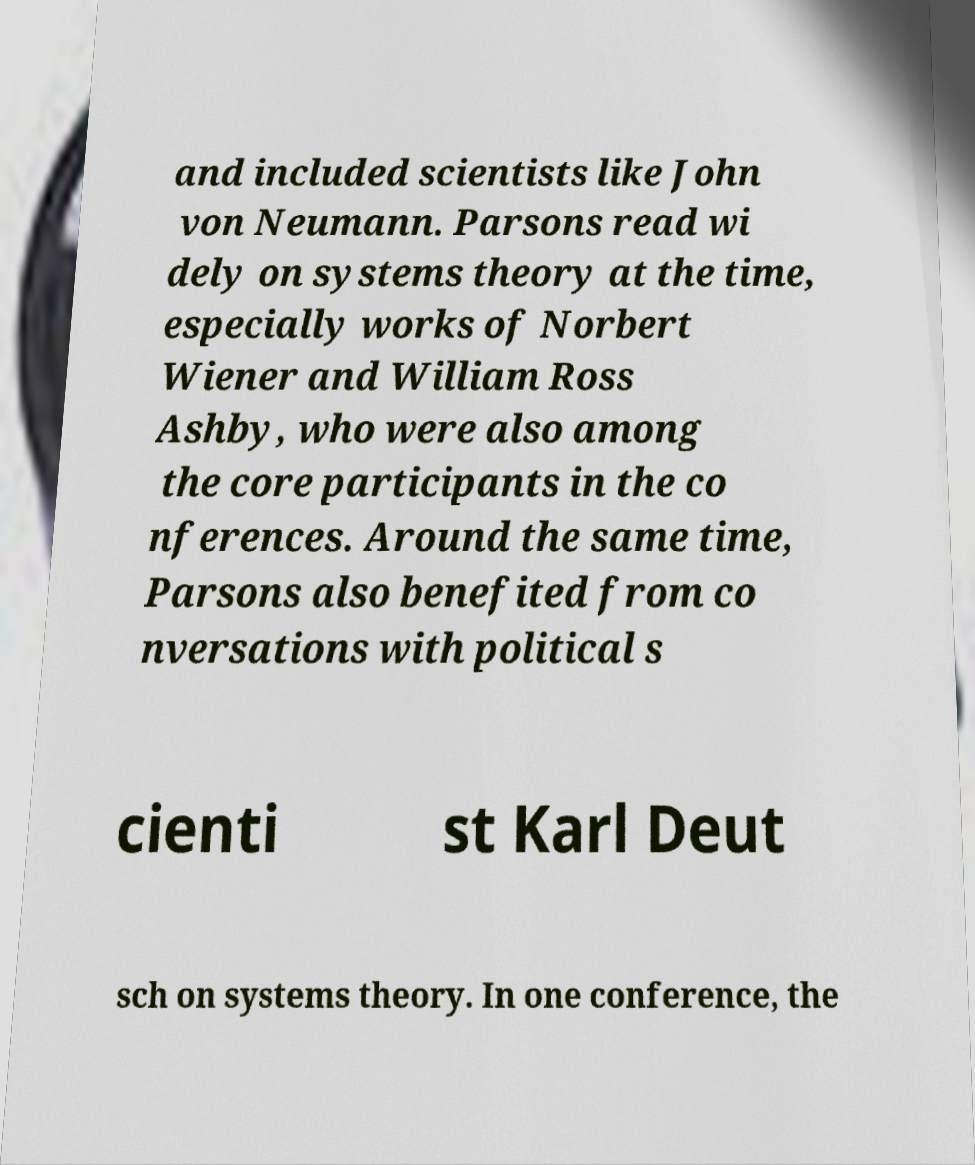Please identify and transcribe the text found in this image. and included scientists like John von Neumann. Parsons read wi dely on systems theory at the time, especially works of Norbert Wiener and William Ross Ashby, who were also among the core participants in the co nferences. Around the same time, Parsons also benefited from co nversations with political s cienti st Karl Deut sch on systems theory. In one conference, the 